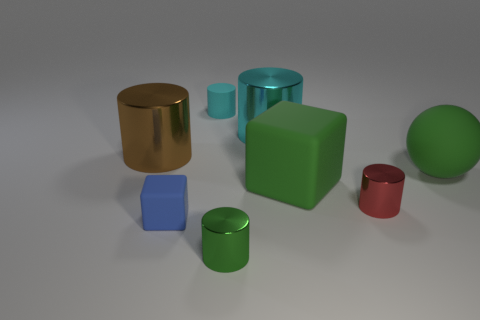There is a large shiny thing that is right of the small cyan rubber object; does it have the same shape as the small thing in front of the blue matte cube?
Your answer should be compact. Yes. How many objects are metallic things or cylinders that are to the right of the large brown metallic object?
Keep it short and to the point. 5. Is the material of the green sphere right of the large brown cylinder the same as the cube that is behind the blue rubber object?
Provide a short and direct response. Yes. There is a rubber cylinder; what number of cyan cylinders are right of it?
Give a very brief answer. 1. How many green things are either tiny shiny cylinders or small matte objects?
Your answer should be compact. 1. There is a green block that is the same size as the green rubber sphere; what is it made of?
Your answer should be very brief. Rubber. The matte object that is right of the small blue cube and on the left side of the big cyan metal thing has what shape?
Offer a terse response. Cylinder. What is the color of the other matte object that is the same size as the blue thing?
Make the answer very short. Cyan. Do the cyan object that is right of the tiny cyan rubber thing and the cylinder that is right of the large cyan cylinder have the same size?
Make the answer very short. No. There is a cyan cylinder right of the small matte thing on the right side of the rubber cube in front of the small red cylinder; what is its size?
Keep it short and to the point. Large. 